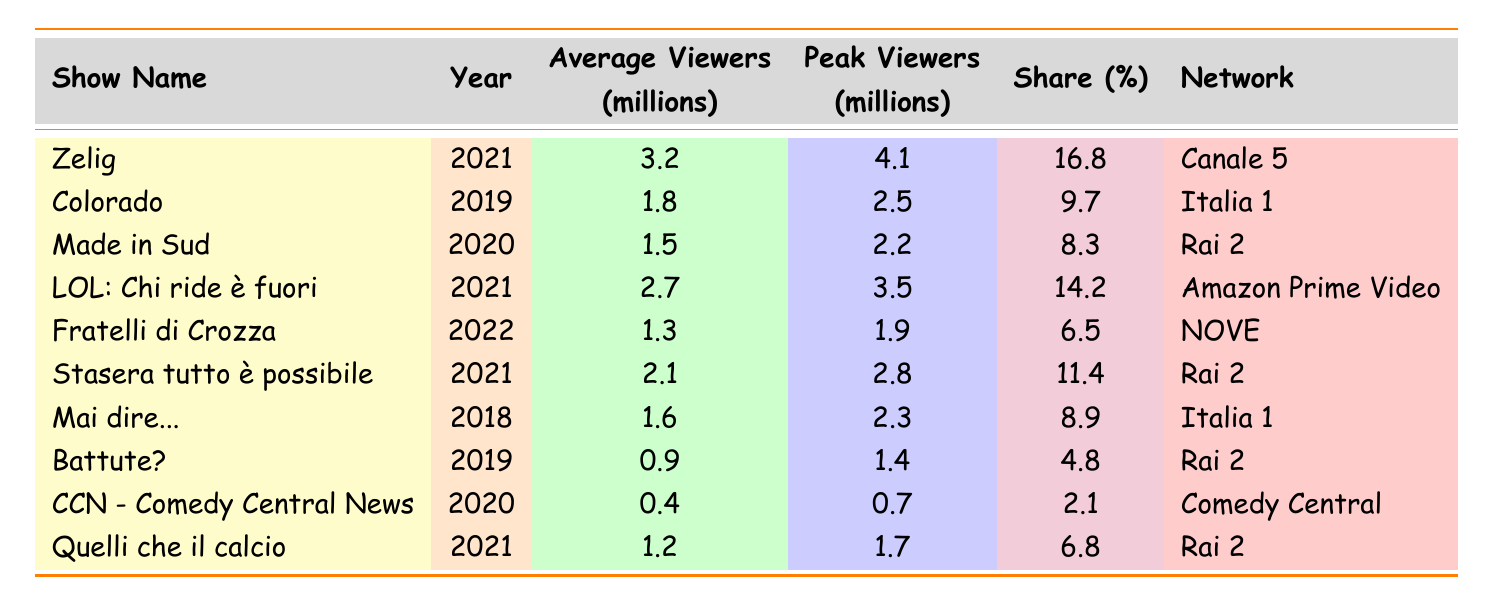What is the show with the highest average viewers? Looking at the "Average Viewers" column, "Zelig" has the highest value of 3.2 million viewers.
Answer: Zelig Which network aired "LOL: Chi ride è fuori"? The "Network" column shows that "LOL: Chi ride è fuori" was aired on "Amazon Prime Video".
Answer: Amazon Prime Video What is the peak viewership for "Fratelli di Crozza"? The table lists the peak viewers for "Fratelli di Crozza" as 1.9 million.
Answer: 1.9 million Which show had the lowest share percentage, and what was that percentage? "CCN - Comedy Central News" had the lowest share at 2.1%.
Answer: 2.1% What is the average viewership of the shows aired on Rai 2? The average of the viewerships is (1.5 + 2.1 + 1.3 + 1.2) / 4 = 1.525 million.
Answer: 1.525 million Did "Battute?" have more average viewers than "Made in Sud"? The average viewers for "Battute?" is 0.9 million while "Made in Sud" has 1.5 million, so "Battute?" had fewer viewers.
Answer: No What is the difference between the peak viewers of "Zelig" and "LOL: Chi ride è fuori"? "Zelig" had a peak of 4.1 million, and "LOL: Chi ride è fuori" had a peak of 3.5 million. The difference is 4.1 - 3.5 = 0.6 million.
Answer: 0.6 million What is the total average viewership of the shows broadcasted by Italia 1? The total average viewership for shows by Italia 1 is (1.8 + 1.6) = 3.4 million.
Answer: 3.4 million Which show has a higher average viewership: "Colorado" or "Stasera tutto è possibile"? "Colorado" has 1.8 million average viewers and "Stasera tutto è possibile" has 2.1 million, making "Stasera tutto è possibile" higher.
Answer: Stasera tutto è possibile Is it true that "Quelli che il calcio" had more peak viewers than "Battute?"? "Quelli che il calcio" had 1.7 million peak viewers, whereas "Battute?" had 1.4 million, so this statement is true.
Answer: Yes 